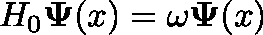<formula> <loc_0><loc_0><loc_500><loc_500>H _ { 0 } \Psi ( x ) = \omega \Psi ( x )</formula> 